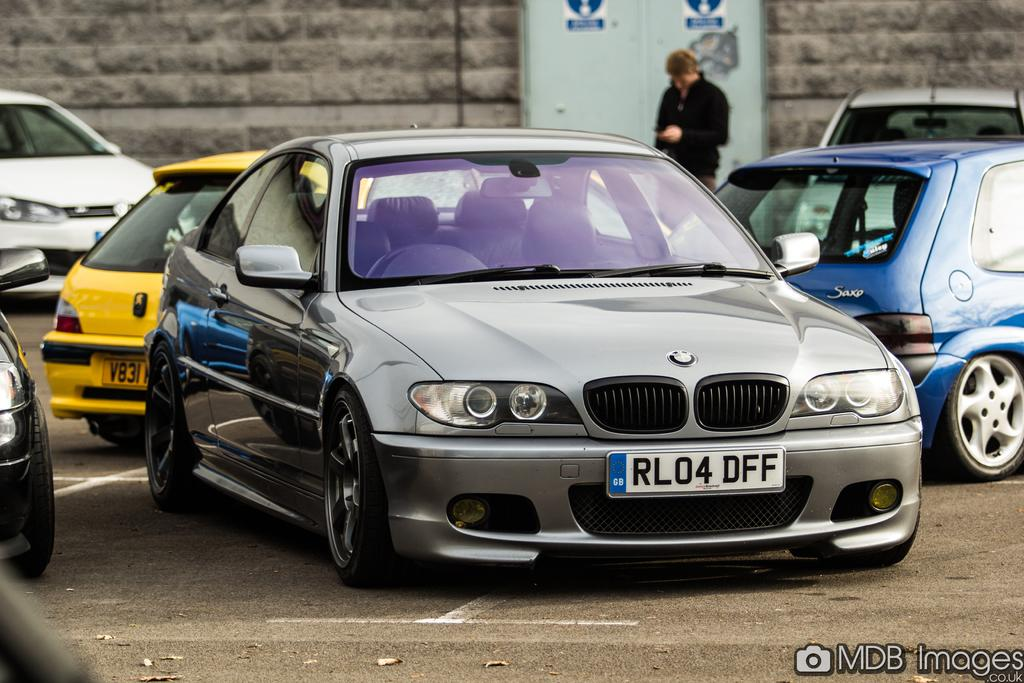<image>
Render a clear and concise summary of the photo. A silver BMW with the license plate of RL04 DFF 